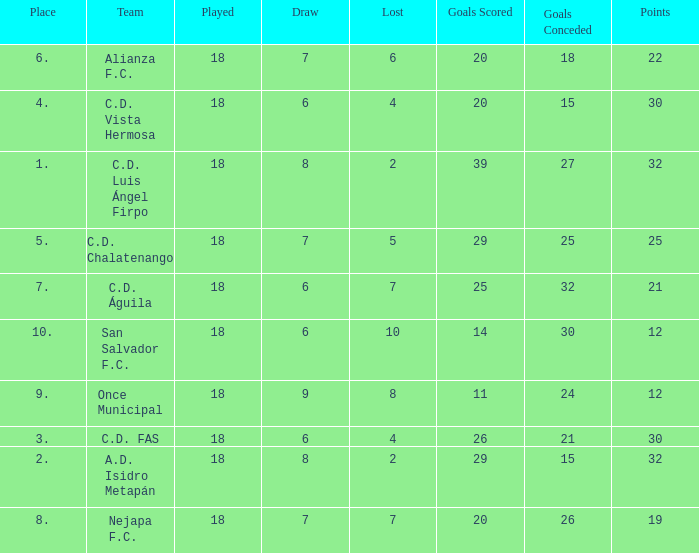What is the sum of draw with a lost smaller than 6, and a place of 5, and a goals scored less than 29? None. 